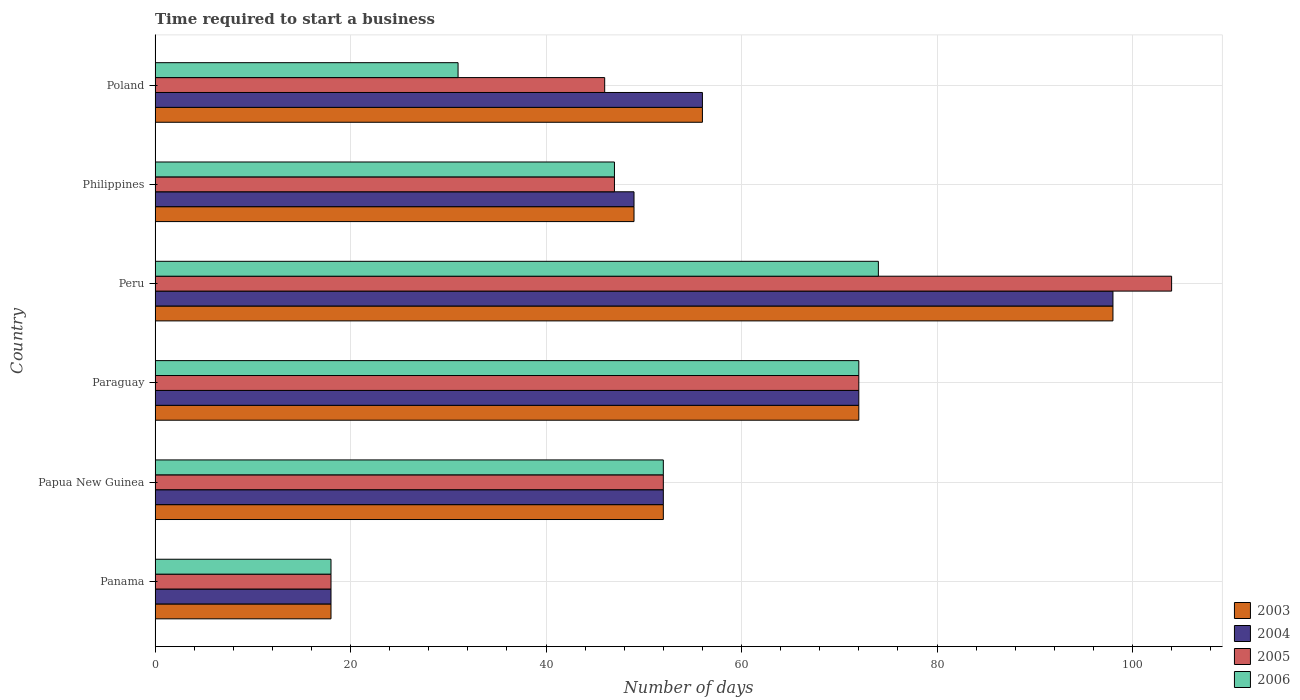How many groups of bars are there?
Your answer should be compact. 6. Are the number of bars per tick equal to the number of legend labels?
Provide a succinct answer. Yes. What is the label of the 2nd group of bars from the top?
Make the answer very short. Philippines. In how many cases, is the number of bars for a given country not equal to the number of legend labels?
Make the answer very short. 0. What is the number of days required to start a business in 2004 in Philippines?
Make the answer very short. 49. Across all countries, what is the maximum number of days required to start a business in 2005?
Ensure brevity in your answer.  104. In which country was the number of days required to start a business in 2003 minimum?
Ensure brevity in your answer.  Panama. What is the total number of days required to start a business in 2006 in the graph?
Your answer should be very brief. 294. What is the difference between the number of days required to start a business in 2004 in Paraguay and that in Poland?
Your response must be concise. 16. What is the average number of days required to start a business in 2004 per country?
Provide a short and direct response. 57.5. What is the difference between the number of days required to start a business in 2003 and number of days required to start a business in 2004 in Philippines?
Your answer should be very brief. 0. What is the ratio of the number of days required to start a business in 2006 in Panama to that in Papua New Guinea?
Your response must be concise. 0.35. Is the difference between the number of days required to start a business in 2003 in Panama and Peru greater than the difference between the number of days required to start a business in 2004 in Panama and Peru?
Give a very brief answer. No. What is the difference between the highest and the second highest number of days required to start a business in 2005?
Give a very brief answer. 32. Is the sum of the number of days required to start a business in 2006 in Panama and Poland greater than the maximum number of days required to start a business in 2003 across all countries?
Offer a terse response. No. Is it the case that in every country, the sum of the number of days required to start a business in 2004 and number of days required to start a business in 2003 is greater than the sum of number of days required to start a business in 2006 and number of days required to start a business in 2005?
Keep it short and to the point. No. What does the 1st bar from the top in Philippines represents?
Make the answer very short. 2006. Is it the case that in every country, the sum of the number of days required to start a business in 2006 and number of days required to start a business in 2005 is greater than the number of days required to start a business in 2004?
Your answer should be compact. Yes. How many countries are there in the graph?
Provide a succinct answer. 6. What is the difference between two consecutive major ticks on the X-axis?
Provide a short and direct response. 20. Are the values on the major ticks of X-axis written in scientific E-notation?
Offer a terse response. No. Does the graph contain grids?
Provide a succinct answer. Yes. Where does the legend appear in the graph?
Make the answer very short. Bottom right. What is the title of the graph?
Keep it short and to the point. Time required to start a business. Does "1976" appear as one of the legend labels in the graph?
Provide a succinct answer. No. What is the label or title of the X-axis?
Ensure brevity in your answer.  Number of days. What is the label or title of the Y-axis?
Offer a very short reply. Country. What is the Number of days in 2003 in Panama?
Your answer should be compact. 18. What is the Number of days in 2004 in Panama?
Give a very brief answer. 18. What is the Number of days in 2005 in Panama?
Your response must be concise. 18. What is the Number of days of 2003 in Papua New Guinea?
Your answer should be very brief. 52. What is the Number of days of 2005 in Papua New Guinea?
Ensure brevity in your answer.  52. What is the Number of days of 2004 in Paraguay?
Make the answer very short. 72. What is the Number of days of 2006 in Paraguay?
Your answer should be compact. 72. What is the Number of days in 2003 in Peru?
Make the answer very short. 98. What is the Number of days in 2005 in Peru?
Your response must be concise. 104. What is the Number of days of 2005 in Philippines?
Your answer should be compact. 47. What is the Number of days in 2006 in Poland?
Provide a short and direct response. 31. Across all countries, what is the maximum Number of days of 2003?
Keep it short and to the point. 98. Across all countries, what is the maximum Number of days of 2004?
Your answer should be very brief. 98. Across all countries, what is the maximum Number of days in 2005?
Provide a short and direct response. 104. Across all countries, what is the maximum Number of days of 2006?
Make the answer very short. 74. Across all countries, what is the minimum Number of days of 2003?
Your answer should be compact. 18. Across all countries, what is the minimum Number of days of 2004?
Keep it short and to the point. 18. Across all countries, what is the minimum Number of days in 2005?
Provide a succinct answer. 18. Across all countries, what is the minimum Number of days in 2006?
Offer a terse response. 18. What is the total Number of days in 2003 in the graph?
Your answer should be very brief. 345. What is the total Number of days in 2004 in the graph?
Provide a succinct answer. 345. What is the total Number of days of 2005 in the graph?
Ensure brevity in your answer.  339. What is the total Number of days in 2006 in the graph?
Provide a succinct answer. 294. What is the difference between the Number of days of 2003 in Panama and that in Papua New Guinea?
Offer a terse response. -34. What is the difference between the Number of days in 2004 in Panama and that in Papua New Guinea?
Your answer should be very brief. -34. What is the difference between the Number of days of 2005 in Panama and that in Papua New Guinea?
Keep it short and to the point. -34. What is the difference between the Number of days in 2006 in Panama and that in Papua New Guinea?
Your response must be concise. -34. What is the difference between the Number of days in 2003 in Panama and that in Paraguay?
Ensure brevity in your answer.  -54. What is the difference between the Number of days of 2004 in Panama and that in Paraguay?
Your answer should be very brief. -54. What is the difference between the Number of days in 2005 in Panama and that in Paraguay?
Ensure brevity in your answer.  -54. What is the difference between the Number of days in 2006 in Panama and that in Paraguay?
Keep it short and to the point. -54. What is the difference between the Number of days in 2003 in Panama and that in Peru?
Provide a succinct answer. -80. What is the difference between the Number of days in 2004 in Panama and that in Peru?
Offer a very short reply. -80. What is the difference between the Number of days in 2005 in Panama and that in Peru?
Your answer should be very brief. -86. What is the difference between the Number of days in 2006 in Panama and that in Peru?
Your response must be concise. -56. What is the difference between the Number of days in 2003 in Panama and that in Philippines?
Provide a short and direct response. -31. What is the difference between the Number of days in 2004 in Panama and that in Philippines?
Provide a succinct answer. -31. What is the difference between the Number of days of 2006 in Panama and that in Philippines?
Give a very brief answer. -29. What is the difference between the Number of days of 2003 in Panama and that in Poland?
Ensure brevity in your answer.  -38. What is the difference between the Number of days in 2004 in Panama and that in Poland?
Your answer should be compact. -38. What is the difference between the Number of days of 2005 in Panama and that in Poland?
Offer a very short reply. -28. What is the difference between the Number of days in 2006 in Panama and that in Poland?
Offer a very short reply. -13. What is the difference between the Number of days in 2003 in Papua New Guinea and that in Peru?
Provide a succinct answer. -46. What is the difference between the Number of days in 2004 in Papua New Guinea and that in Peru?
Provide a succinct answer. -46. What is the difference between the Number of days of 2005 in Papua New Guinea and that in Peru?
Ensure brevity in your answer.  -52. What is the difference between the Number of days in 2006 in Papua New Guinea and that in Peru?
Make the answer very short. -22. What is the difference between the Number of days in 2003 in Papua New Guinea and that in Philippines?
Offer a very short reply. 3. What is the difference between the Number of days of 2006 in Papua New Guinea and that in Philippines?
Provide a short and direct response. 5. What is the difference between the Number of days in 2006 in Papua New Guinea and that in Poland?
Give a very brief answer. 21. What is the difference between the Number of days in 2004 in Paraguay and that in Peru?
Your answer should be very brief. -26. What is the difference between the Number of days of 2005 in Paraguay and that in Peru?
Make the answer very short. -32. What is the difference between the Number of days in 2003 in Paraguay and that in Philippines?
Offer a very short reply. 23. What is the difference between the Number of days in 2004 in Paraguay and that in Philippines?
Ensure brevity in your answer.  23. What is the difference between the Number of days in 2005 in Paraguay and that in Philippines?
Provide a short and direct response. 25. What is the difference between the Number of days of 2005 in Paraguay and that in Poland?
Offer a terse response. 26. What is the difference between the Number of days in 2006 in Paraguay and that in Poland?
Your answer should be compact. 41. What is the difference between the Number of days of 2004 in Peru and that in Philippines?
Your response must be concise. 49. What is the difference between the Number of days in 2004 in Peru and that in Poland?
Provide a short and direct response. 42. What is the difference between the Number of days in 2006 in Peru and that in Poland?
Provide a short and direct response. 43. What is the difference between the Number of days in 2003 in Philippines and that in Poland?
Your answer should be very brief. -7. What is the difference between the Number of days of 2005 in Philippines and that in Poland?
Offer a terse response. 1. What is the difference between the Number of days in 2006 in Philippines and that in Poland?
Keep it short and to the point. 16. What is the difference between the Number of days of 2003 in Panama and the Number of days of 2004 in Papua New Guinea?
Offer a terse response. -34. What is the difference between the Number of days of 2003 in Panama and the Number of days of 2005 in Papua New Guinea?
Offer a very short reply. -34. What is the difference between the Number of days in 2003 in Panama and the Number of days in 2006 in Papua New Guinea?
Your answer should be very brief. -34. What is the difference between the Number of days of 2004 in Panama and the Number of days of 2005 in Papua New Guinea?
Give a very brief answer. -34. What is the difference between the Number of days in 2004 in Panama and the Number of days in 2006 in Papua New Guinea?
Keep it short and to the point. -34. What is the difference between the Number of days of 2005 in Panama and the Number of days of 2006 in Papua New Guinea?
Your response must be concise. -34. What is the difference between the Number of days in 2003 in Panama and the Number of days in 2004 in Paraguay?
Make the answer very short. -54. What is the difference between the Number of days in 2003 in Panama and the Number of days in 2005 in Paraguay?
Provide a short and direct response. -54. What is the difference between the Number of days of 2003 in Panama and the Number of days of 2006 in Paraguay?
Ensure brevity in your answer.  -54. What is the difference between the Number of days in 2004 in Panama and the Number of days in 2005 in Paraguay?
Keep it short and to the point. -54. What is the difference between the Number of days in 2004 in Panama and the Number of days in 2006 in Paraguay?
Ensure brevity in your answer.  -54. What is the difference between the Number of days in 2005 in Panama and the Number of days in 2006 in Paraguay?
Offer a very short reply. -54. What is the difference between the Number of days of 2003 in Panama and the Number of days of 2004 in Peru?
Your answer should be very brief. -80. What is the difference between the Number of days in 2003 in Panama and the Number of days in 2005 in Peru?
Provide a short and direct response. -86. What is the difference between the Number of days in 2003 in Panama and the Number of days in 2006 in Peru?
Your answer should be compact. -56. What is the difference between the Number of days of 2004 in Panama and the Number of days of 2005 in Peru?
Provide a short and direct response. -86. What is the difference between the Number of days of 2004 in Panama and the Number of days of 2006 in Peru?
Provide a short and direct response. -56. What is the difference between the Number of days of 2005 in Panama and the Number of days of 2006 in Peru?
Your response must be concise. -56. What is the difference between the Number of days in 2003 in Panama and the Number of days in 2004 in Philippines?
Your answer should be compact. -31. What is the difference between the Number of days of 2004 in Panama and the Number of days of 2005 in Philippines?
Your answer should be very brief. -29. What is the difference between the Number of days of 2005 in Panama and the Number of days of 2006 in Philippines?
Ensure brevity in your answer.  -29. What is the difference between the Number of days of 2003 in Panama and the Number of days of 2004 in Poland?
Make the answer very short. -38. What is the difference between the Number of days of 2003 in Panama and the Number of days of 2006 in Poland?
Keep it short and to the point. -13. What is the difference between the Number of days of 2004 in Panama and the Number of days of 2005 in Poland?
Give a very brief answer. -28. What is the difference between the Number of days of 2005 in Panama and the Number of days of 2006 in Poland?
Provide a short and direct response. -13. What is the difference between the Number of days of 2003 in Papua New Guinea and the Number of days of 2006 in Paraguay?
Your answer should be compact. -20. What is the difference between the Number of days in 2004 in Papua New Guinea and the Number of days in 2006 in Paraguay?
Provide a short and direct response. -20. What is the difference between the Number of days of 2003 in Papua New Guinea and the Number of days of 2004 in Peru?
Offer a very short reply. -46. What is the difference between the Number of days of 2003 in Papua New Guinea and the Number of days of 2005 in Peru?
Give a very brief answer. -52. What is the difference between the Number of days of 2004 in Papua New Guinea and the Number of days of 2005 in Peru?
Offer a very short reply. -52. What is the difference between the Number of days in 2003 in Papua New Guinea and the Number of days in 2005 in Philippines?
Ensure brevity in your answer.  5. What is the difference between the Number of days in 2004 in Papua New Guinea and the Number of days in 2005 in Philippines?
Give a very brief answer. 5. What is the difference between the Number of days in 2005 in Papua New Guinea and the Number of days in 2006 in Philippines?
Your answer should be compact. 5. What is the difference between the Number of days in 2003 in Papua New Guinea and the Number of days in 2006 in Poland?
Give a very brief answer. 21. What is the difference between the Number of days of 2005 in Papua New Guinea and the Number of days of 2006 in Poland?
Ensure brevity in your answer.  21. What is the difference between the Number of days of 2003 in Paraguay and the Number of days of 2004 in Peru?
Your answer should be very brief. -26. What is the difference between the Number of days of 2003 in Paraguay and the Number of days of 2005 in Peru?
Ensure brevity in your answer.  -32. What is the difference between the Number of days of 2004 in Paraguay and the Number of days of 2005 in Peru?
Your response must be concise. -32. What is the difference between the Number of days in 2004 in Paraguay and the Number of days in 2006 in Peru?
Your response must be concise. -2. What is the difference between the Number of days in 2005 in Paraguay and the Number of days in 2006 in Peru?
Your response must be concise. -2. What is the difference between the Number of days in 2003 in Paraguay and the Number of days in 2006 in Philippines?
Give a very brief answer. 25. What is the difference between the Number of days of 2004 in Paraguay and the Number of days of 2006 in Philippines?
Provide a succinct answer. 25. What is the difference between the Number of days of 2005 in Paraguay and the Number of days of 2006 in Philippines?
Provide a succinct answer. 25. What is the difference between the Number of days in 2003 in Paraguay and the Number of days in 2006 in Poland?
Offer a terse response. 41. What is the difference between the Number of days in 2004 in Paraguay and the Number of days in 2006 in Poland?
Keep it short and to the point. 41. What is the difference between the Number of days of 2005 in Paraguay and the Number of days of 2006 in Poland?
Offer a very short reply. 41. What is the difference between the Number of days of 2003 in Peru and the Number of days of 2006 in Philippines?
Your answer should be compact. 51. What is the difference between the Number of days in 2004 in Peru and the Number of days in 2005 in Philippines?
Provide a short and direct response. 51. What is the difference between the Number of days in 2004 in Peru and the Number of days in 2006 in Philippines?
Keep it short and to the point. 51. What is the difference between the Number of days in 2003 in Peru and the Number of days in 2004 in Poland?
Make the answer very short. 42. What is the difference between the Number of days of 2003 in Peru and the Number of days of 2006 in Poland?
Offer a terse response. 67. What is the difference between the Number of days in 2004 in Peru and the Number of days in 2005 in Poland?
Ensure brevity in your answer.  52. What is the difference between the Number of days of 2004 in Peru and the Number of days of 2006 in Poland?
Ensure brevity in your answer.  67. What is the difference between the Number of days in 2003 in Philippines and the Number of days in 2006 in Poland?
Keep it short and to the point. 18. What is the average Number of days in 2003 per country?
Keep it short and to the point. 57.5. What is the average Number of days in 2004 per country?
Your answer should be very brief. 57.5. What is the average Number of days in 2005 per country?
Provide a succinct answer. 56.5. What is the average Number of days in 2006 per country?
Your answer should be compact. 49. What is the difference between the Number of days of 2003 and Number of days of 2005 in Panama?
Offer a very short reply. 0. What is the difference between the Number of days in 2003 and Number of days in 2006 in Panama?
Provide a short and direct response. 0. What is the difference between the Number of days of 2004 and Number of days of 2006 in Panama?
Provide a short and direct response. 0. What is the difference between the Number of days of 2003 and Number of days of 2004 in Papua New Guinea?
Offer a very short reply. 0. What is the difference between the Number of days of 2003 and Number of days of 2006 in Papua New Guinea?
Give a very brief answer. 0. What is the difference between the Number of days in 2004 and Number of days in 2005 in Papua New Guinea?
Provide a succinct answer. 0. What is the difference between the Number of days of 2003 and Number of days of 2004 in Paraguay?
Your answer should be compact. 0. What is the difference between the Number of days of 2004 and Number of days of 2006 in Paraguay?
Your response must be concise. 0. What is the difference between the Number of days in 2005 and Number of days in 2006 in Paraguay?
Make the answer very short. 0. What is the difference between the Number of days of 2003 and Number of days of 2006 in Peru?
Your answer should be compact. 24. What is the difference between the Number of days in 2004 and Number of days in 2006 in Peru?
Ensure brevity in your answer.  24. What is the difference between the Number of days of 2003 and Number of days of 2004 in Philippines?
Your response must be concise. 0. What is the difference between the Number of days of 2003 and Number of days of 2005 in Philippines?
Keep it short and to the point. 2. What is the difference between the Number of days in 2003 and Number of days in 2006 in Philippines?
Offer a very short reply. 2. What is the difference between the Number of days in 2004 and Number of days in 2006 in Philippines?
Give a very brief answer. 2. What is the difference between the Number of days of 2005 and Number of days of 2006 in Philippines?
Offer a terse response. 0. What is the difference between the Number of days in 2003 and Number of days in 2005 in Poland?
Give a very brief answer. 10. What is the difference between the Number of days in 2003 and Number of days in 2006 in Poland?
Your answer should be compact. 25. What is the difference between the Number of days of 2004 and Number of days of 2005 in Poland?
Provide a succinct answer. 10. What is the difference between the Number of days of 2004 and Number of days of 2006 in Poland?
Offer a very short reply. 25. What is the difference between the Number of days in 2005 and Number of days in 2006 in Poland?
Your answer should be very brief. 15. What is the ratio of the Number of days of 2003 in Panama to that in Papua New Guinea?
Provide a succinct answer. 0.35. What is the ratio of the Number of days of 2004 in Panama to that in Papua New Guinea?
Your answer should be very brief. 0.35. What is the ratio of the Number of days of 2005 in Panama to that in Papua New Guinea?
Your response must be concise. 0.35. What is the ratio of the Number of days in 2006 in Panama to that in Papua New Guinea?
Your response must be concise. 0.35. What is the ratio of the Number of days in 2003 in Panama to that in Paraguay?
Keep it short and to the point. 0.25. What is the ratio of the Number of days of 2004 in Panama to that in Paraguay?
Make the answer very short. 0.25. What is the ratio of the Number of days of 2003 in Panama to that in Peru?
Provide a succinct answer. 0.18. What is the ratio of the Number of days of 2004 in Panama to that in Peru?
Offer a terse response. 0.18. What is the ratio of the Number of days of 2005 in Panama to that in Peru?
Give a very brief answer. 0.17. What is the ratio of the Number of days in 2006 in Panama to that in Peru?
Your answer should be very brief. 0.24. What is the ratio of the Number of days in 2003 in Panama to that in Philippines?
Provide a succinct answer. 0.37. What is the ratio of the Number of days of 2004 in Panama to that in Philippines?
Your answer should be very brief. 0.37. What is the ratio of the Number of days in 2005 in Panama to that in Philippines?
Give a very brief answer. 0.38. What is the ratio of the Number of days in 2006 in Panama to that in Philippines?
Provide a succinct answer. 0.38. What is the ratio of the Number of days of 2003 in Panama to that in Poland?
Your response must be concise. 0.32. What is the ratio of the Number of days in 2004 in Panama to that in Poland?
Give a very brief answer. 0.32. What is the ratio of the Number of days of 2005 in Panama to that in Poland?
Your answer should be compact. 0.39. What is the ratio of the Number of days in 2006 in Panama to that in Poland?
Your answer should be compact. 0.58. What is the ratio of the Number of days in 2003 in Papua New Guinea to that in Paraguay?
Your answer should be very brief. 0.72. What is the ratio of the Number of days in 2004 in Papua New Guinea to that in Paraguay?
Keep it short and to the point. 0.72. What is the ratio of the Number of days of 2005 in Papua New Guinea to that in Paraguay?
Provide a succinct answer. 0.72. What is the ratio of the Number of days in 2006 in Papua New Guinea to that in Paraguay?
Your answer should be very brief. 0.72. What is the ratio of the Number of days of 2003 in Papua New Guinea to that in Peru?
Provide a short and direct response. 0.53. What is the ratio of the Number of days of 2004 in Papua New Guinea to that in Peru?
Make the answer very short. 0.53. What is the ratio of the Number of days of 2005 in Papua New Guinea to that in Peru?
Give a very brief answer. 0.5. What is the ratio of the Number of days in 2006 in Papua New Guinea to that in Peru?
Provide a succinct answer. 0.7. What is the ratio of the Number of days of 2003 in Papua New Guinea to that in Philippines?
Your response must be concise. 1.06. What is the ratio of the Number of days in 2004 in Papua New Guinea to that in Philippines?
Offer a terse response. 1.06. What is the ratio of the Number of days in 2005 in Papua New Guinea to that in Philippines?
Provide a short and direct response. 1.11. What is the ratio of the Number of days in 2006 in Papua New Guinea to that in Philippines?
Your answer should be compact. 1.11. What is the ratio of the Number of days of 2004 in Papua New Guinea to that in Poland?
Provide a succinct answer. 0.93. What is the ratio of the Number of days of 2005 in Papua New Guinea to that in Poland?
Make the answer very short. 1.13. What is the ratio of the Number of days in 2006 in Papua New Guinea to that in Poland?
Ensure brevity in your answer.  1.68. What is the ratio of the Number of days in 2003 in Paraguay to that in Peru?
Give a very brief answer. 0.73. What is the ratio of the Number of days in 2004 in Paraguay to that in Peru?
Your answer should be compact. 0.73. What is the ratio of the Number of days of 2005 in Paraguay to that in Peru?
Make the answer very short. 0.69. What is the ratio of the Number of days in 2003 in Paraguay to that in Philippines?
Ensure brevity in your answer.  1.47. What is the ratio of the Number of days of 2004 in Paraguay to that in Philippines?
Make the answer very short. 1.47. What is the ratio of the Number of days of 2005 in Paraguay to that in Philippines?
Your response must be concise. 1.53. What is the ratio of the Number of days of 2006 in Paraguay to that in Philippines?
Ensure brevity in your answer.  1.53. What is the ratio of the Number of days of 2003 in Paraguay to that in Poland?
Give a very brief answer. 1.29. What is the ratio of the Number of days of 2004 in Paraguay to that in Poland?
Provide a short and direct response. 1.29. What is the ratio of the Number of days in 2005 in Paraguay to that in Poland?
Your answer should be compact. 1.57. What is the ratio of the Number of days of 2006 in Paraguay to that in Poland?
Offer a very short reply. 2.32. What is the ratio of the Number of days of 2005 in Peru to that in Philippines?
Provide a succinct answer. 2.21. What is the ratio of the Number of days of 2006 in Peru to that in Philippines?
Offer a very short reply. 1.57. What is the ratio of the Number of days of 2005 in Peru to that in Poland?
Keep it short and to the point. 2.26. What is the ratio of the Number of days of 2006 in Peru to that in Poland?
Keep it short and to the point. 2.39. What is the ratio of the Number of days in 2003 in Philippines to that in Poland?
Your answer should be compact. 0.88. What is the ratio of the Number of days of 2005 in Philippines to that in Poland?
Provide a succinct answer. 1.02. What is the ratio of the Number of days in 2006 in Philippines to that in Poland?
Provide a succinct answer. 1.52. What is the difference between the highest and the second highest Number of days of 2004?
Your answer should be compact. 26. What is the difference between the highest and the lowest Number of days in 2006?
Make the answer very short. 56. 